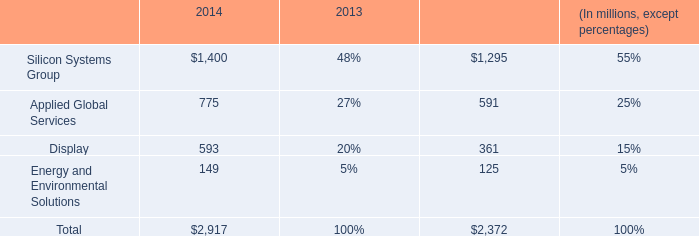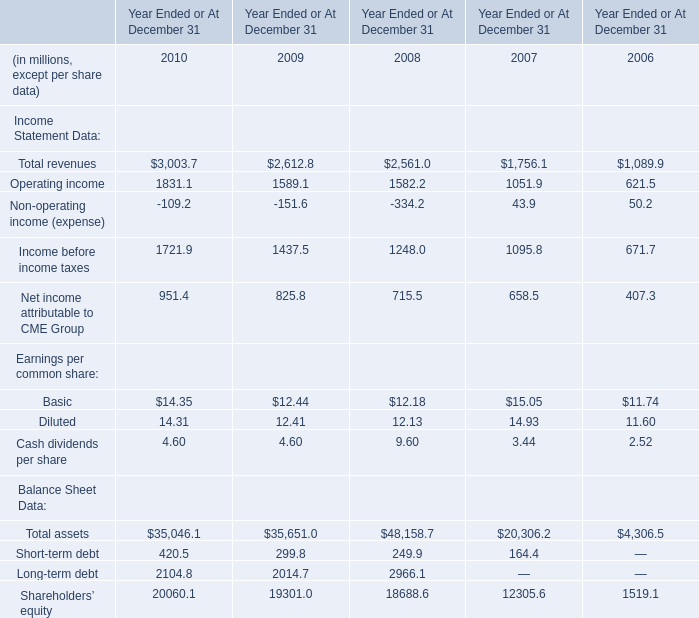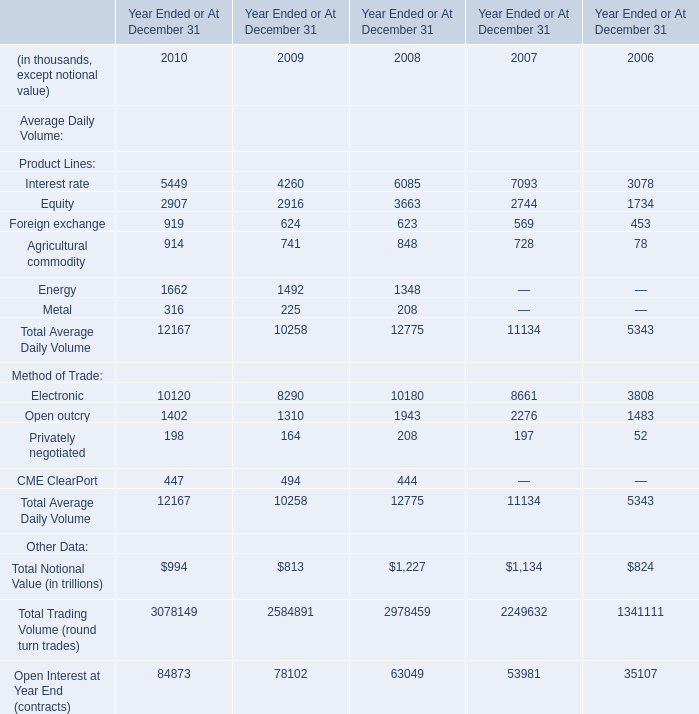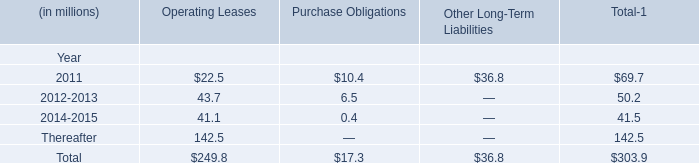In what year / sections is Operating income positive? 
Answer: 2006; 2007; 2008; 2009; 2010. 